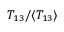<formula> <loc_0><loc_0><loc_500><loc_500>T _ { 1 3 } / \langle { T _ { 1 3 } }</formula> 